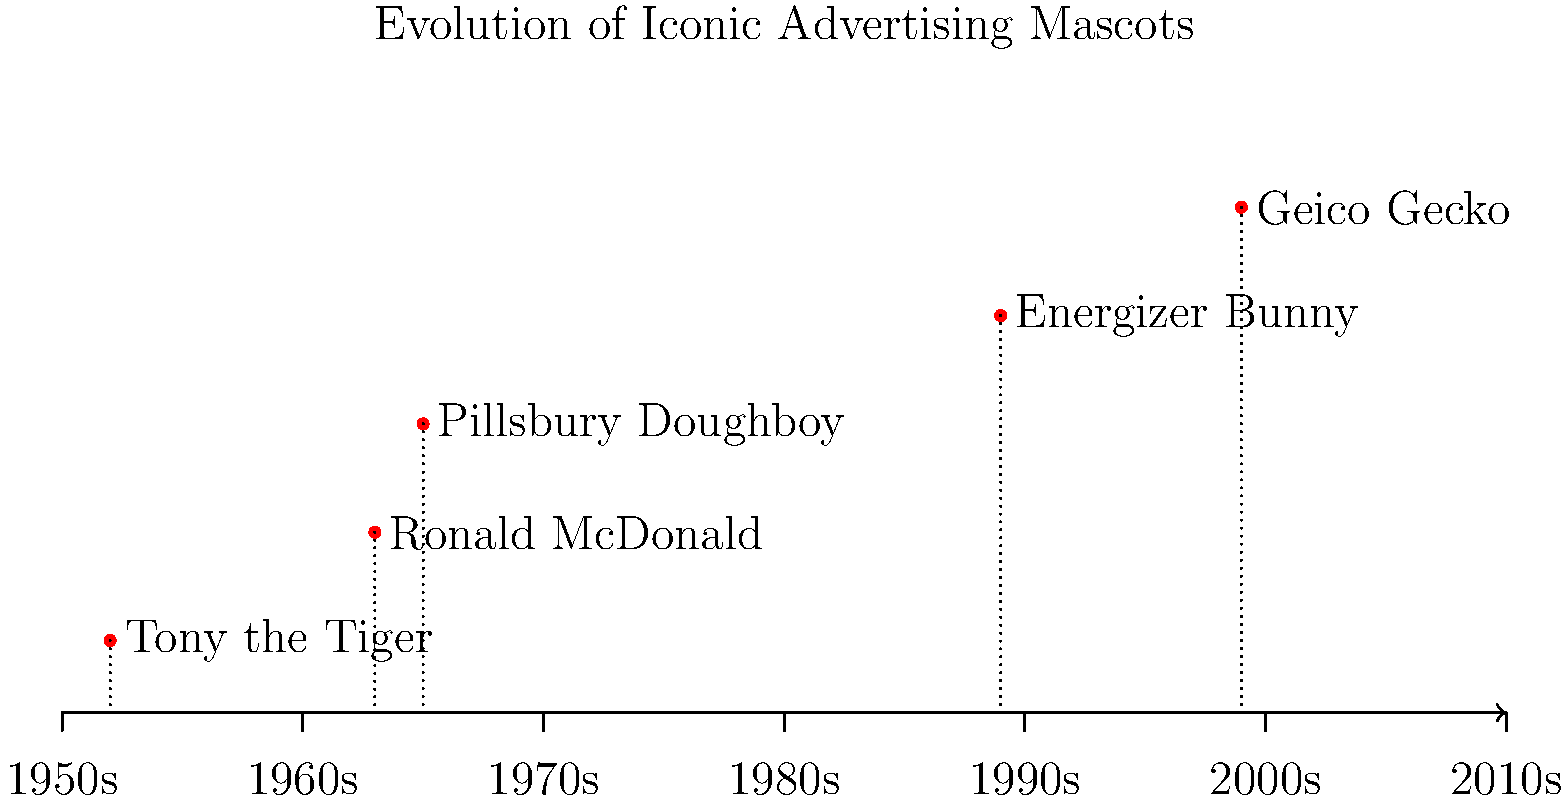Based on the timeline diagram, which iconic advertising mascot was introduced earliest and remained relevant through subsequent decades? To answer this question, we need to analyze the timeline diagram of iconic advertising mascots:

1. Identify the mascots on the timeline:
   - Tony the Tiger
   - Ronald McDonald
   - Pillsbury Doughboy
   - Energizer Bunny
   - Geico Gecko

2. Determine their introduction years:
   - Tony the Tiger: 1952
   - Ronald McDonald: 1963
   - Pillsbury Doughboy: 1965
   - Energizer Bunny: 1989
   - Geico Gecko: 1999

3. Compare the introduction years:
   Tony the Tiger was introduced in 1952, which is the earliest among all mascots shown.

4. Consider longevity:
   The timeline extends to the 2010s, and Tony the Tiger's presence spans the entire timeline, indicating its continued relevance through subsequent decades.

5. Conclusion:
   Tony the Tiger, introduced in 1952, is the earliest mascot that has remained relevant through the decades shown on the timeline.
Answer: Tony the Tiger 